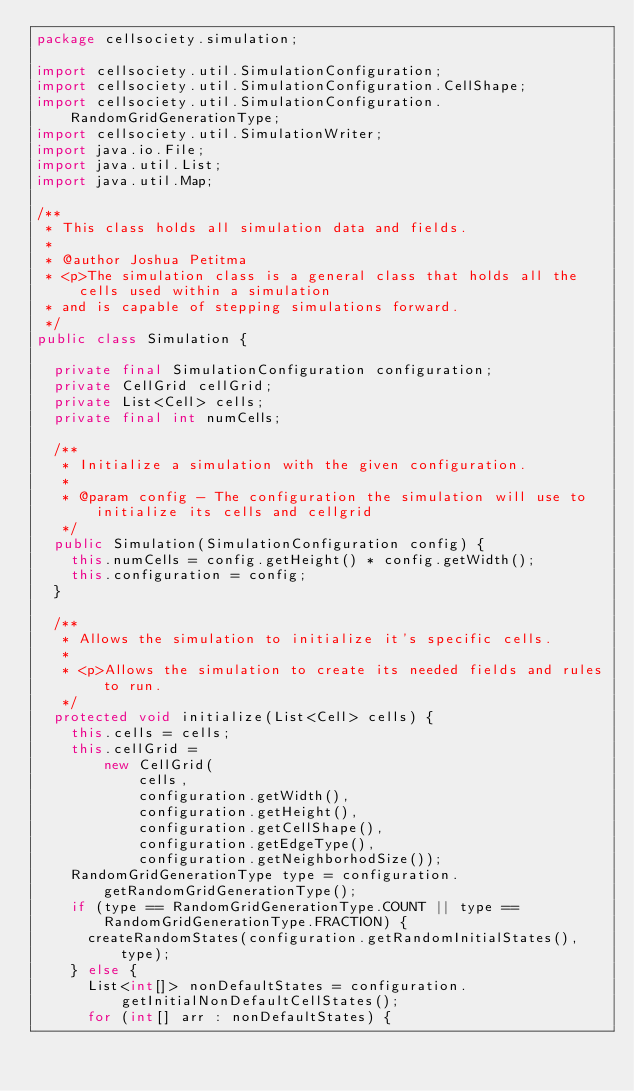Convert code to text. <code><loc_0><loc_0><loc_500><loc_500><_Java_>package cellsociety.simulation;

import cellsociety.util.SimulationConfiguration;
import cellsociety.util.SimulationConfiguration.CellShape;
import cellsociety.util.SimulationConfiguration.RandomGridGenerationType;
import cellsociety.util.SimulationWriter;
import java.io.File;
import java.util.List;
import java.util.Map;

/**
 * This class holds all simulation data and fields.
 *
 * @author Joshua Petitma
 * <p>The simulation class is a general class that holds all the cells used within a simulation
 * and is capable of stepping simulations forward.
 */
public class Simulation {

  private final SimulationConfiguration configuration;
  private CellGrid cellGrid;
  private List<Cell> cells;
  private final int numCells;

  /**
   * Initialize a simulation with the given configuration.
   *
   * @param config - The configuration the simulation will use to initialize its cells and cellgrid
   */
  public Simulation(SimulationConfiguration config) {
    this.numCells = config.getHeight() * config.getWidth();
    this.configuration = config;
  }

  /**
   * Allows the simulation to initialize it's specific cells.
   *
   * <p>Allows the simulation to create its needed fields and rules to run.
   */
  protected void initialize(List<Cell> cells) {
    this.cells = cells;
    this.cellGrid =
        new CellGrid(
            cells,
            configuration.getWidth(),
            configuration.getHeight(),
            configuration.getCellShape(),
            configuration.getEdgeType(),
            configuration.getNeighborhodSize());
    RandomGridGenerationType type = configuration.getRandomGridGenerationType();
    if (type == RandomGridGenerationType.COUNT || type == RandomGridGenerationType.FRACTION) {
      createRandomStates(configuration.getRandomInitialStates(), type);
    } else {
      List<int[]> nonDefaultStates = configuration.getInitialNonDefaultCellStates();
      for (int[] arr : nonDefaultStates) {</code> 